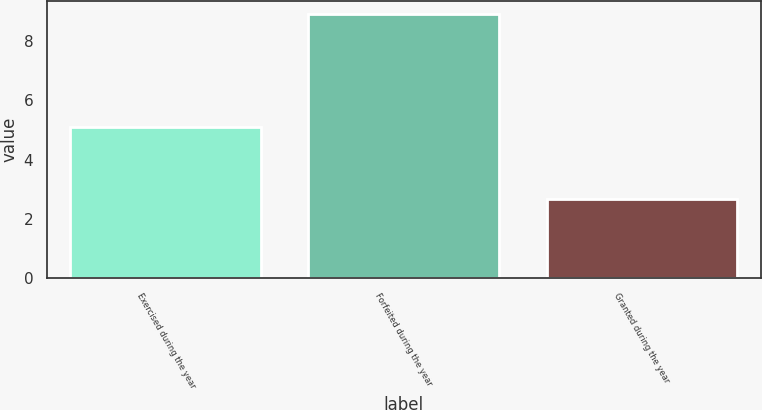Convert chart to OTSL. <chart><loc_0><loc_0><loc_500><loc_500><bar_chart><fcel>Exercised during the year<fcel>Forfeited during the year<fcel>Granted during the year<nl><fcel>5.1<fcel>8.9<fcel>2.66<nl></chart> 